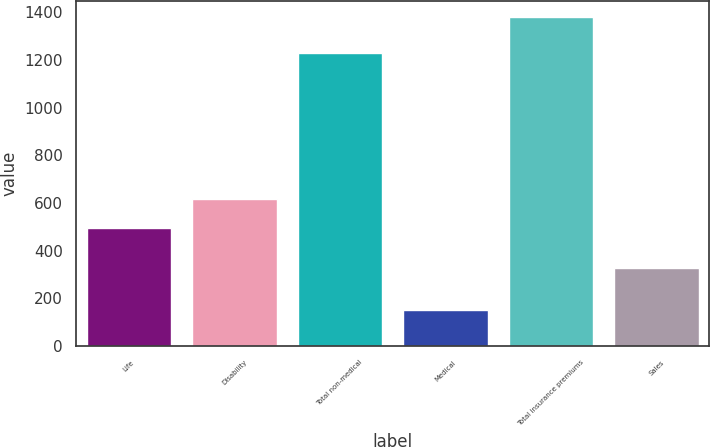Convert chart to OTSL. <chart><loc_0><loc_0><loc_500><loc_500><bar_chart><fcel>Life<fcel>Disability<fcel>Total non-medical<fcel>Medical<fcel>Total insurance premiums<fcel>Sales<nl><fcel>494<fcel>617.1<fcel>1231<fcel>149<fcel>1380<fcel>326<nl></chart> 